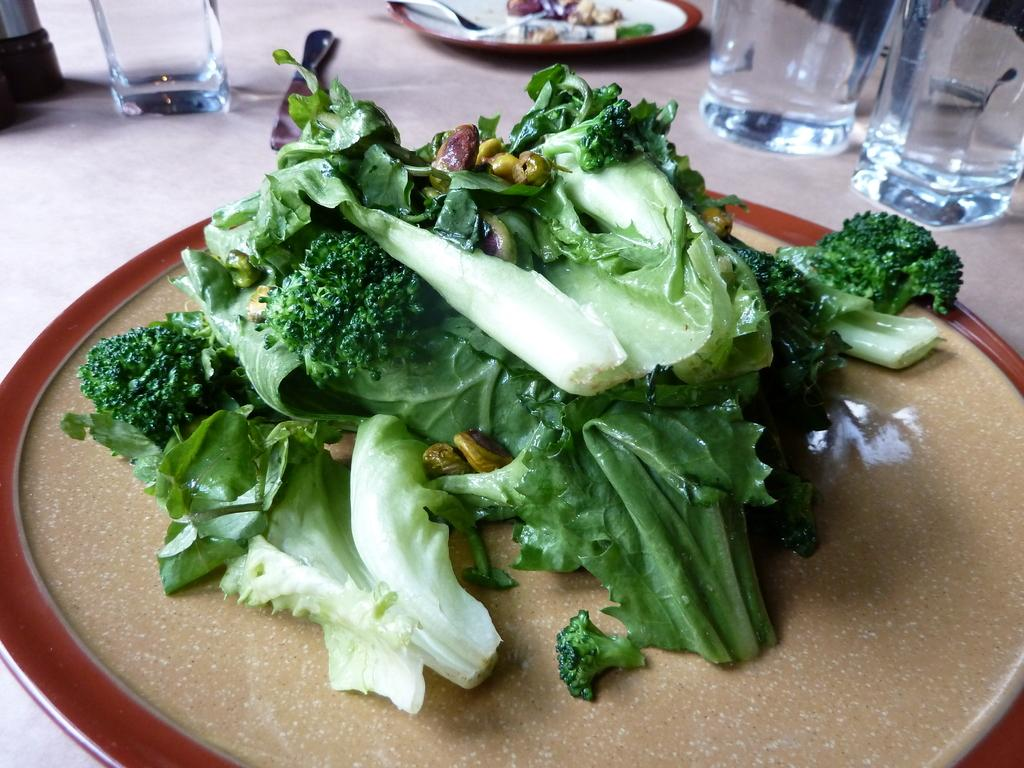What type of dishware can be seen in the image? There are plates and glasses in the image. What utensil is present in the image? There is a knife in the image. What type of food is visible in the image? Green vegetables are visible in the image. What letter is written on the plate in the image? There are no letters written on the plate in the image; it is a plain dish. 